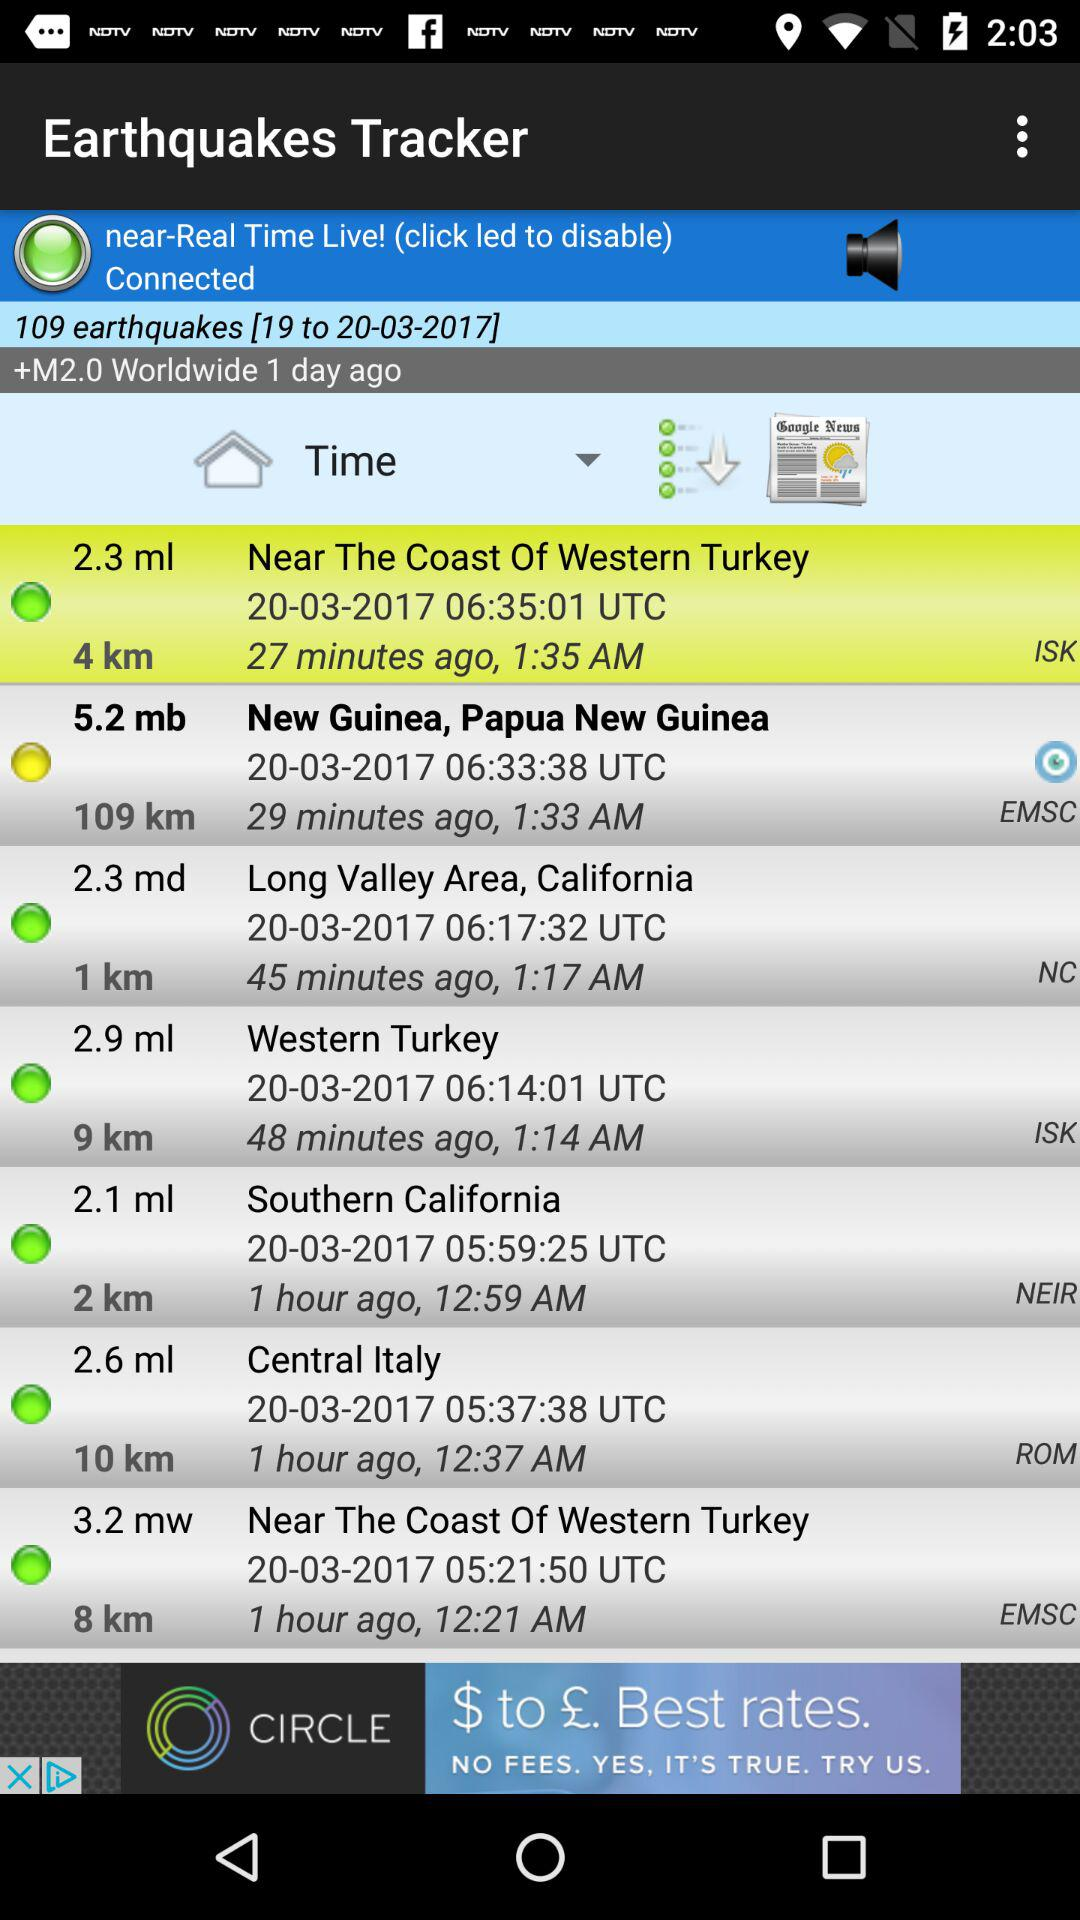What is the application name? The application name is "Earthquakes Tracker". 